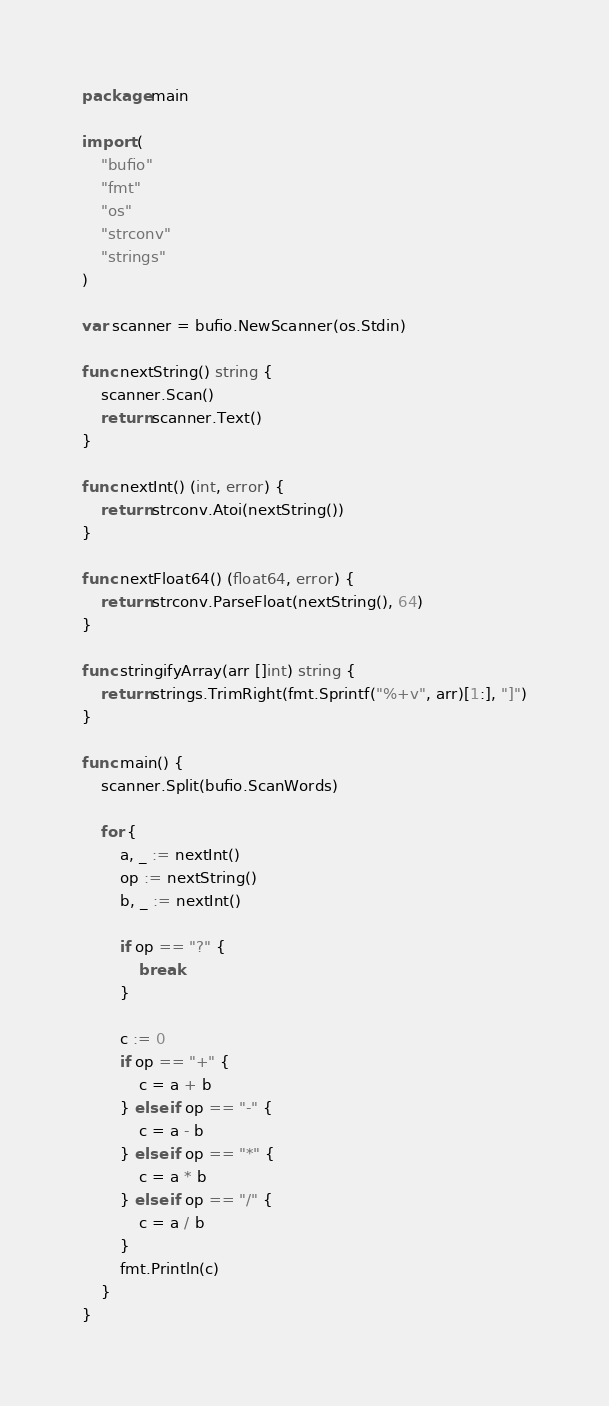<code> <loc_0><loc_0><loc_500><loc_500><_Go_>package main

import (
	"bufio"
	"fmt"
	"os"
	"strconv"
	"strings"
)

var scanner = bufio.NewScanner(os.Stdin)

func nextString() string {
	scanner.Scan()
	return scanner.Text()
}

func nextInt() (int, error) {
	return strconv.Atoi(nextString())
}

func nextFloat64() (float64, error) {
	return strconv.ParseFloat(nextString(), 64)
}

func stringifyArray(arr []int) string {
	return strings.TrimRight(fmt.Sprintf("%+v", arr)[1:], "]")
}

func main() {
	scanner.Split(bufio.ScanWords)

	for {
		a, _ := nextInt()
		op := nextString()
		b, _ := nextInt()

		if op == "?" {
			break
		}

		c := 0
		if op == "+" {
			c = a + b
		} else if op == "-" {
			c = a - b
		} else if op == "*" {
			c = a * b
		} else if op == "/" {
			c = a / b
		}
		fmt.Println(c)
	}
}

</code> 